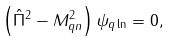Convert formula to latex. <formula><loc_0><loc_0><loc_500><loc_500>\left ( \hat { \Pi } ^ { 2 } - M _ { q n } ^ { 2 } \right ) \psi _ { q \ln } = 0 ,</formula> 